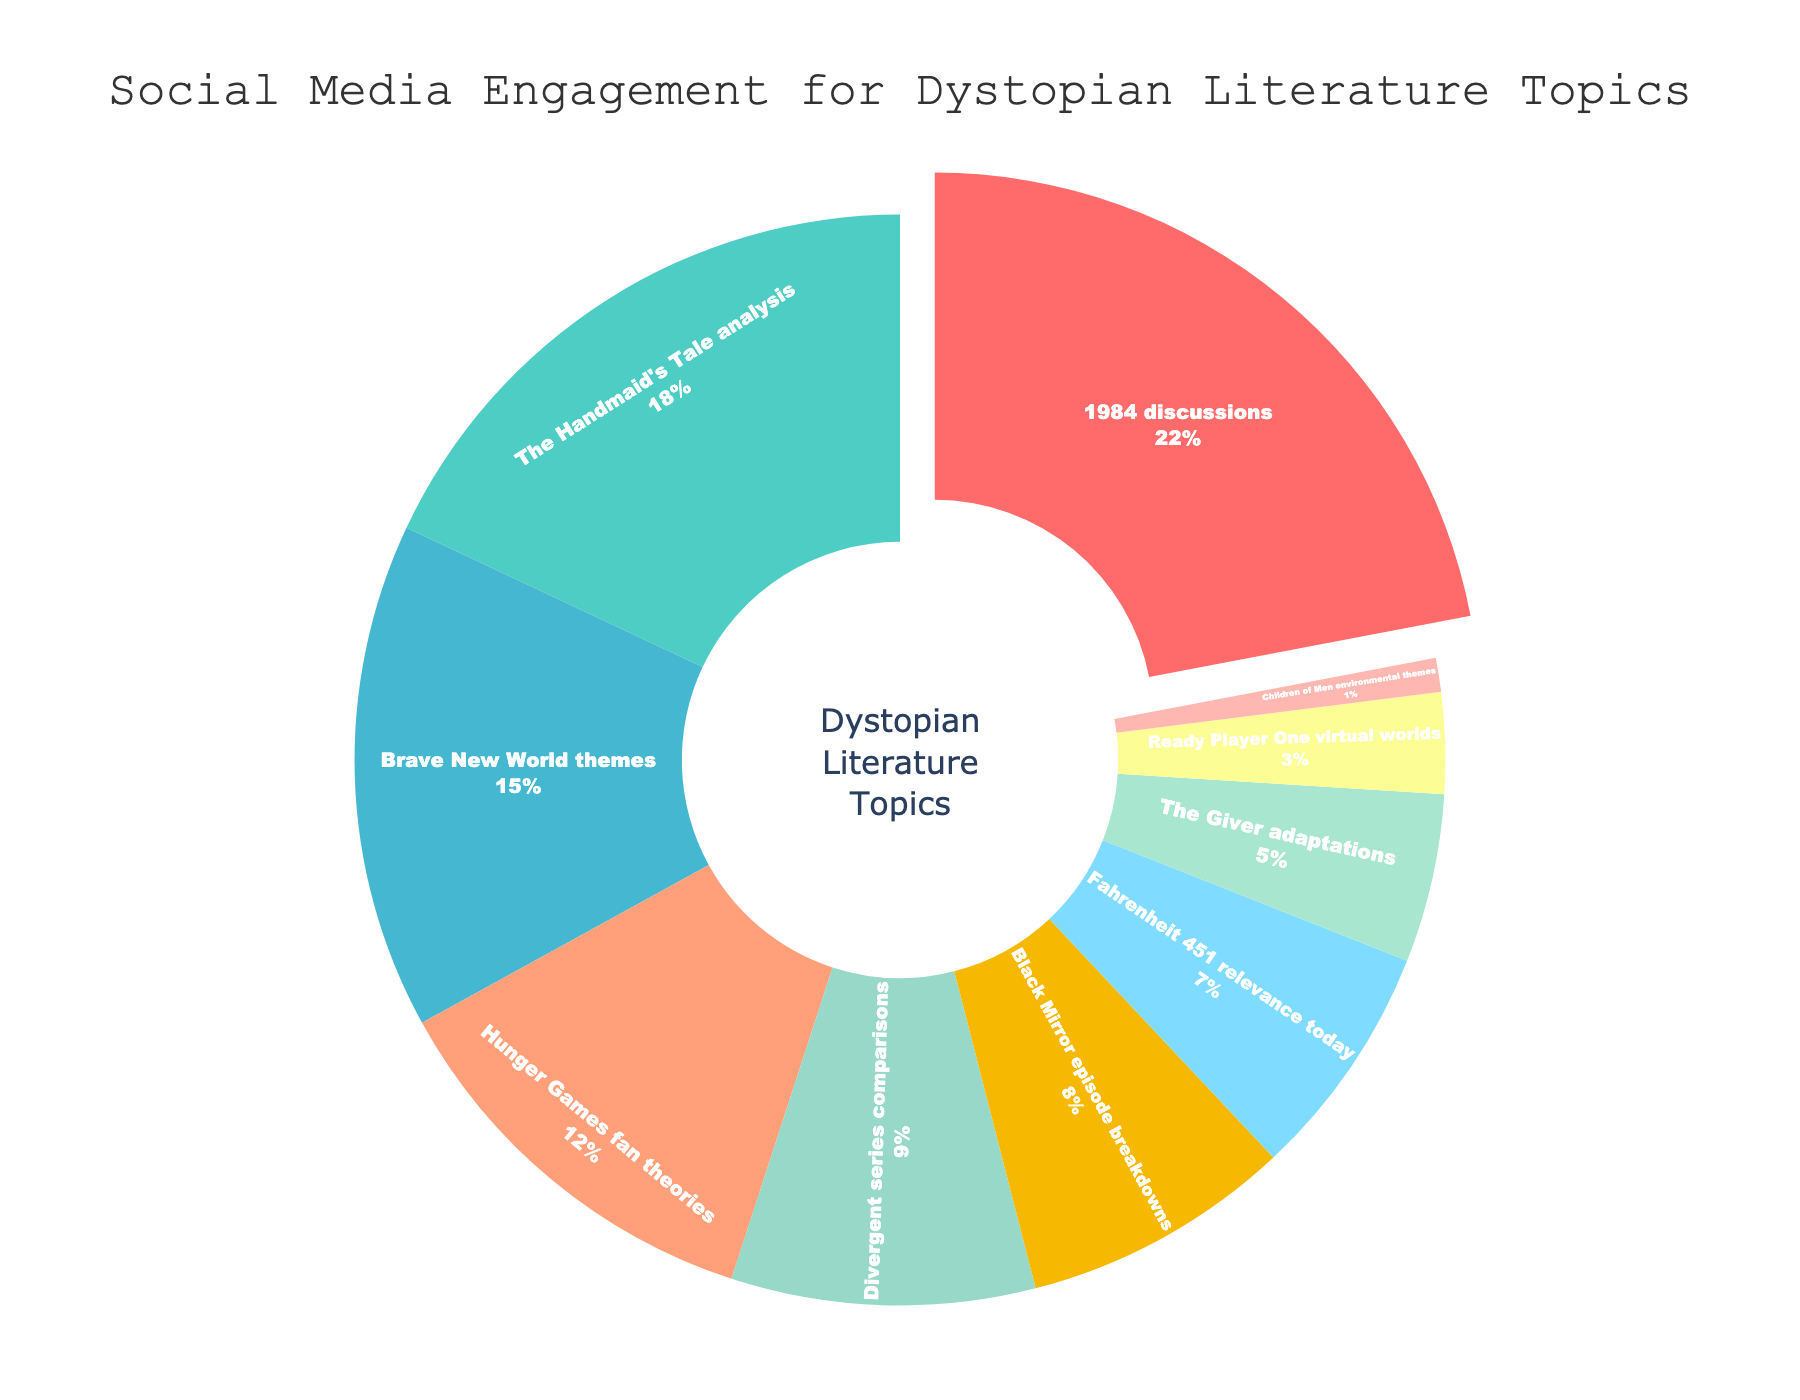What's the most discussed dystopian literature topic? The chart's title indicates it's about social media engagement for dystopian literature topics, and "1984 discussions" has the largest slice at 22%, which clearly stands out.
Answer: 1984 discussions How much more engagement do "1984 discussions" have compared to "The Handmaid's Tale analysis"? "1984 discussions" account for 22% and "The Handmaid's Tale analysis" for 18%. The difference between these percentages is 22% - 18% = 4%.
Answer: 4% What is the combined percentage of discussions for "Hunger Games fan theories" and "Black Mirror episode breakdowns"? The chart shows "Hunger Games fan theories" at 12% and "Black Mirror episode breakdowns" at 8%. Adding these together gives 12% + 8% = 20%.
Answer: 20% Which topic has the least engagement in the chart? Looking at the chart, "Children of Men environmental themes" has only 1%, which is the smallest slice.
Answer: Children of Men environmental themes Are there more engagements on "Brave New World themes" or "Fahrenheit 451 relevance today"? The chart indicates that "Brave New World themes" has 15% and "Fahrenheit 451 relevance today" has 7%. Comparing these, 15% is greater than 7%.
Answer: Brave New World themes How do the engagements for "The Giver adaptations" compare with "Ready Player One virtual worlds"? "The Giver adaptations" has 5% engagement and "Ready Player One virtual worlds" has 3%. Since 5% is greater than 3%, "The Giver adaptations" has higher engagement.
Answer: The Giver adaptations What is the total percentage of topics that have less than 10% engagement each? The chart has "Divergent series comparisons" at 9%, "Black Mirror episode breakdowns" at 8%, "Fahrenheit 451 relevance today" at 7%, "The Giver adaptations" at 5%, "Ready Player One virtual worlds" at 3%, and "Children of Men environmental themes" at 1%. Summing these gives 9% + 8% + 7% + 5% + 3% + 1% = 33%.
Answer: 33% What percentage gap is there between the most engaged topic and the least engaged topic? The most engaged topic, "1984 discussions," has 22%, and the least engaged topic, "Children of Men environmental themes," has 1%. The percentage gap is 22% - 1% = 21%.
Answer: 21% What color represents "Brave New World themes" in the chart? The slice for "Brave New World themes" is notably colored in a shade of blue, distinct from the other colors.
Answer: Blue 